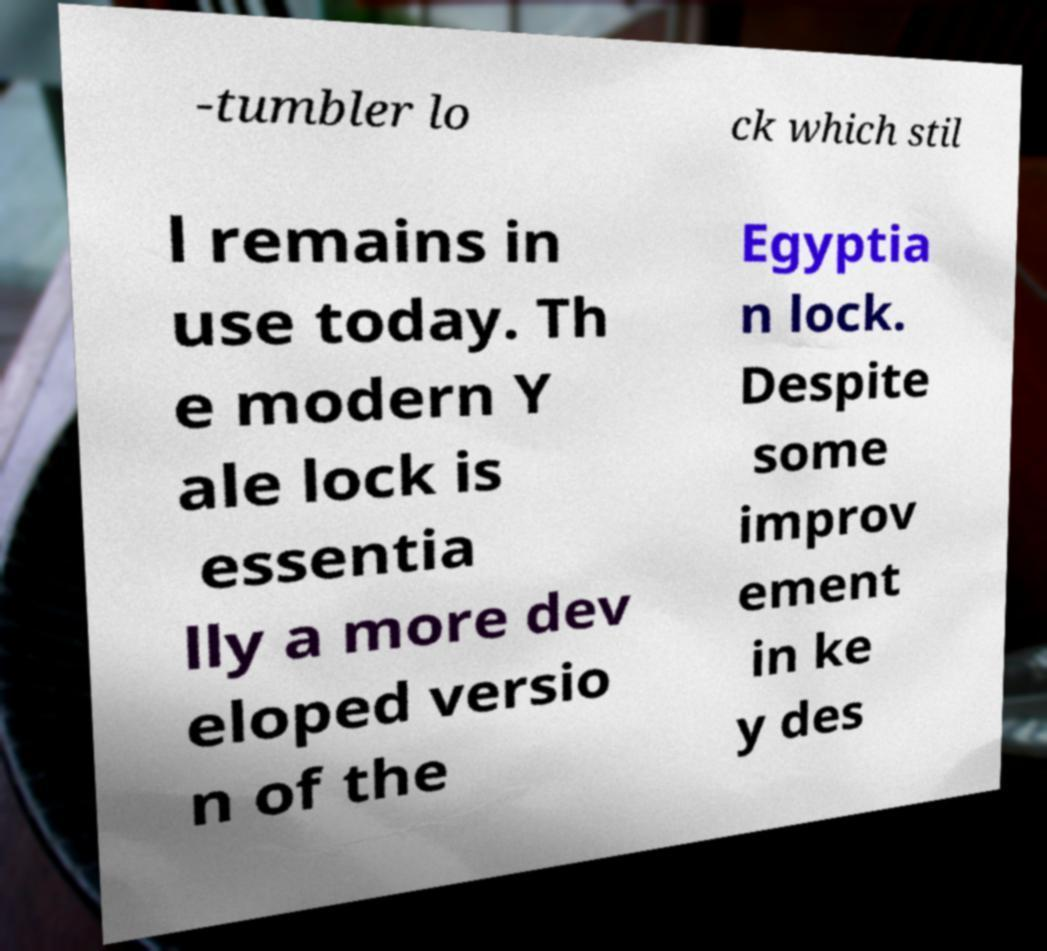I need the written content from this picture converted into text. Can you do that? -tumbler lo ck which stil l remains in use today. Th e modern Y ale lock is essentia lly a more dev eloped versio n of the Egyptia n lock. Despite some improv ement in ke y des 